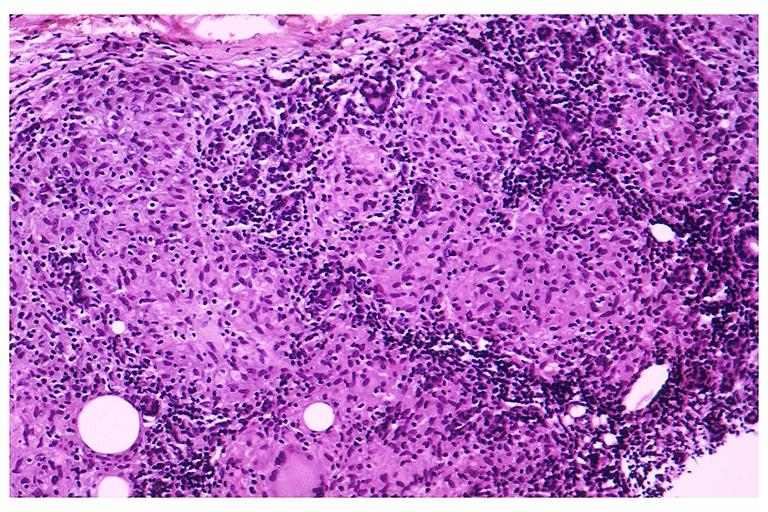what does this image show?
Answer the question using a single word or phrase. Sarcoidosis 